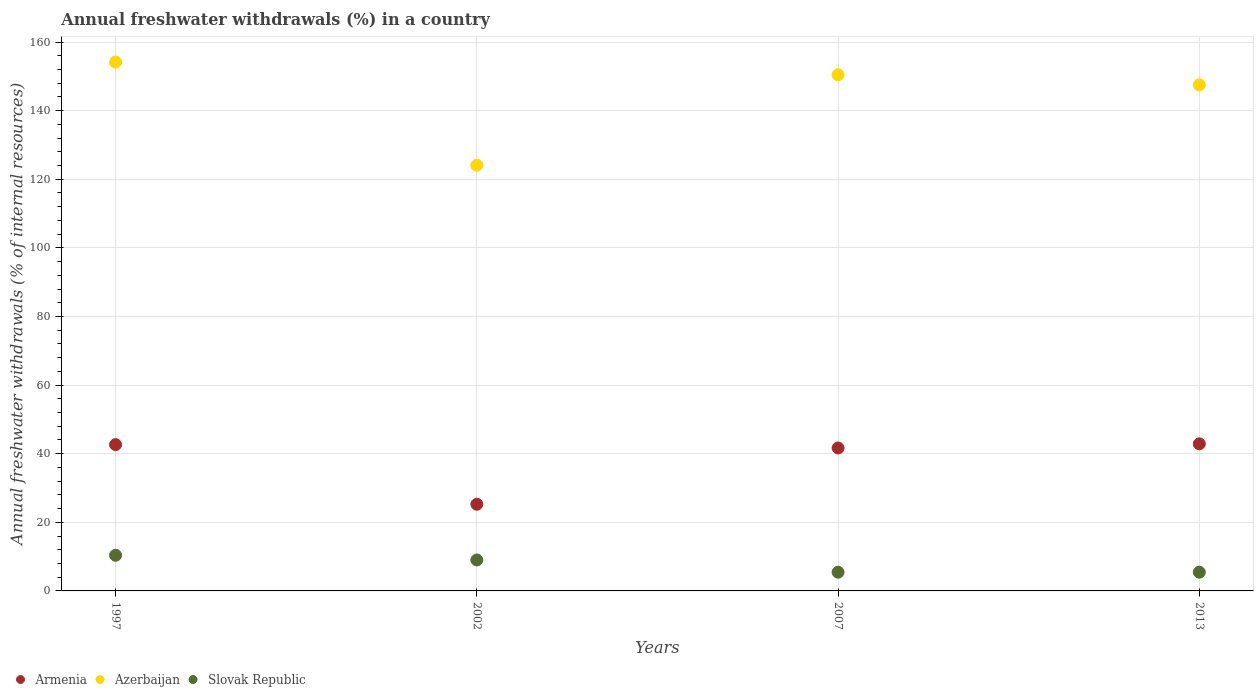How many different coloured dotlines are there?
Your answer should be very brief. 3. Is the number of dotlines equal to the number of legend labels?
Provide a short and direct response. Yes. What is the percentage of annual freshwater withdrawals in Azerbaijan in 2007?
Ensure brevity in your answer.  150.46. Across all years, what is the maximum percentage of annual freshwater withdrawals in Slovak Republic?
Give a very brief answer. 10.4. Across all years, what is the minimum percentage of annual freshwater withdrawals in Armenia?
Offer a terse response. 25.27. In which year was the percentage of annual freshwater withdrawals in Armenia maximum?
Your response must be concise. 2013. In which year was the percentage of annual freshwater withdrawals in Slovak Republic minimum?
Ensure brevity in your answer.  2007. What is the total percentage of annual freshwater withdrawals in Armenia in the graph?
Make the answer very short. 152.46. What is the difference between the percentage of annual freshwater withdrawals in Armenia in 2002 and that in 2007?
Make the answer very short. -16.4. What is the difference between the percentage of annual freshwater withdrawals in Slovak Republic in 2013 and the percentage of annual freshwater withdrawals in Armenia in 2007?
Provide a succinct answer. -36.21. What is the average percentage of annual freshwater withdrawals in Armenia per year?
Offer a very short reply. 38.11. In the year 1997, what is the difference between the percentage of annual freshwater withdrawals in Azerbaijan and percentage of annual freshwater withdrawals in Slovak Republic?
Your answer should be very brief. 143.76. What is the ratio of the percentage of annual freshwater withdrawals in Slovak Republic in 2002 to that in 2013?
Give a very brief answer. 1.65. Is the percentage of annual freshwater withdrawals in Slovak Republic in 2007 less than that in 2013?
Your answer should be compact. No. Is the difference between the percentage of annual freshwater withdrawals in Azerbaijan in 1997 and 2007 greater than the difference between the percentage of annual freshwater withdrawals in Slovak Republic in 1997 and 2007?
Ensure brevity in your answer.  No. What is the difference between the highest and the second highest percentage of annual freshwater withdrawals in Slovak Republic?
Your response must be concise. 1.37. What is the difference between the highest and the lowest percentage of annual freshwater withdrawals in Azerbaijan?
Offer a terse response. 30.07. Does the percentage of annual freshwater withdrawals in Azerbaijan monotonically increase over the years?
Offer a terse response. No. Is the percentage of annual freshwater withdrawals in Slovak Republic strictly greater than the percentage of annual freshwater withdrawals in Azerbaijan over the years?
Your answer should be very brief. No. Is the percentage of annual freshwater withdrawals in Slovak Republic strictly less than the percentage of annual freshwater withdrawals in Armenia over the years?
Your answer should be very brief. Yes. How many years are there in the graph?
Provide a short and direct response. 4. Are the values on the major ticks of Y-axis written in scientific E-notation?
Provide a short and direct response. No. Does the graph contain any zero values?
Your answer should be compact. No. What is the title of the graph?
Your response must be concise. Annual freshwater withdrawals (%) in a country. Does "Vanuatu" appear as one of the legend labels in the graph?
Provide a succinct answer. No. What is the label or title of the Y-axis?
Ensure brevity in your answer.  Annual freshwater withdrawals (% of internal resources). What is the Annual freshwater withdrawals (% of internal resources) of Armenia in 1997?
Provide a succinct answer. 42.64. What is the Annual freshwater withdrawals (% of internal resources) in Azerbaijan in 1997?
Ensure brevity in your answer.  154.16. What is the Annual freshwater withdrawals (% of internal resources) of Slovak Republic in 1997?
Keep it short and to the point. 10.4. What is the Annual freshwater withdrawals (% of internal resources) of Armenia in 2002?
Provide a succinct answer. 25.27. What is the Annual freshwater withdrawals (% of internal resources) in Azerbaijan in 2002?
Keep it short and to the point. 124.09. What is the Annual freshwater withdrawals (% of internal resources) in Slovak Republic in 2002?
Make the answer very short. 9.02. What is the Annual freshwater withdrawals (% of internal resources) in Armenia in 2007?
Offer a terse response. 41.67. What is the Annual freshwater withdrawals (% of internal resources) of Azerbaijan in 2007?
Make the answer very short. 150.46. What is the Annual freshwater withdrawals (% of internal resources) of Slovak Republic in 2007?
Ensure brevity in your answer.  5.46. What is the Annual freshwater withdrawals (% of internal resources) in Armenia in 2013?
Your answer should be very brief. 42.88. What is the Annual freshwater withdrawals (% of internal resources) in Azerbaijan in 2013?
Offer a very short reply. 147.5. What is the Annual freshwater withdrawals (% of internal resources) in Slovak Republic in 2013?
Provide a succinct answer. 5.46. Across all years, what is the maximum Annual freshwater withdrawals (% of internal resources) of Armenia?
Ensure brevity in your answer.  42.88. Across all years, what is the maximum Annual freshwater withdrawals (% of internal resources) in Azerbaijan?
Make the answer very short. 154.16. Across all years, what is the maximum Annual freshwater withdrawals (% of internal resources) in Slovak Republic?
Make the answer very short. 10.4. Across all years, what is the minimum Annual freshwater withdrawals (% of internal resources) of Armenia?
Provide a succinct answer. 25.27. Across all years, what is the minimum Annual freshwater withdrawals (% of internal resources) of Azerbaijan?
Provide a succinct answer. 124.09. Across all years, what is the minimum Annual freshwater withdrawals (% of internal resources) in Slovak Republic?
Give a very brief answer. 5.46. What is the total Annual freshwater withdrawals (% of internal resources) of Armenia in the graph?
Offer a terse response. 152.46. What is the total Annual freshwater withdrawals (% of internal resources) of Azerbaijan in the graph?
Your answer should be very brief. 576.22. What is the total Annual freshwater withdrawals (% of internal resources) of Slovak Republic in the graph?
Your response must be concise. 30.34. What is the difference between the Annual freshwater withdrawals (% of internal resources) of Armenia in 1997 and that in 2002?
Keep it short and to the point. 17.38. What is the difference between the Annual freshwater withdrawals (% of internal resources) of Azerbaijan in 1997 and that in 2002?
Provide a succinct answer. 30.07. What is the difference between the Annual freshwater withdrawals (% of internal resources) in Slovak Republic in 1997 and that in 2002?
Ensure brevity in your answer.  1.37. What is the difference between the Annual freshwater withdrawals (% of internal resources) in Armenia in 1997 and that in 2007?
Make the answer very short. 0.98. What is the difference between the Annual freshwater withdrawals (% of internal resources) of Azerbaijan in 1997 and that in 2007?
Give a very brief answer. 3.7. What is the difference between the Annual freshwater withdrawals (% of internal resources) in Slovak Republic in 1997 and that in 2007?
Provide a succinct answer. 4.94. What is the difference between the Annual freshwater withdrawals (% of internal resources) in Armenia in 1997 and that in 2013?
Provide a short and direct response. -0.23. What is the difference between the Annual freshwater withdrawals (% of internal resources) in Azerbaijan in 1997 and that in 2013?
Your response must be concise. 6.65. What is the difference between the Annual freshwater withdrawals (% of internal resources) of Slovak Republic in 1997 and that in 2013?
Give a very brief answer. 4.94. What is the difference between the Annual freshwater withdrawals (% of internal resources) of Armenia in 2002 and that in 2007?
Provide a succinct answer. -16.4. What is the difference between the Annual freshwater withdrawals (% of internal resources) of Azerbaijan in 2002 and that in 2007?
Provide a short and direct response. -26.37. What is the difference between the Annual freshwater withdrawals (% of internal resources) in Slovak Republic in 2002 and that in 2007?
Make the answer very short. 3.56. What is the difference between the Annual freshwater withdrawals (% of internal resources) of Armenia in 2002 and that in 2013?
Offer a very short reply. -17.61. What is the difference between the Annual freshwater withdrawals (% of internal resources) in Azerbaijan in 2002 and that in 2013?
Offer a terse response. -23.41. What is the difference between the Annual freshwater withdrawals (% of internal resources) in Slovak Republic in 2002 and that in 2013?
Offer a very short reply. 3.56. What is the difference between the Annual freshwater withdrawals (% of internal resources) in Armenia in 2007 and that in 2013?
Ensure brevity in your answer.  -1.21. What is the difference between the Annual freshwater withdrawals (% of internal resources) of Azerbaijan in 2007 and that in 2013?
Your response must be concise. 2.96. What is the difference between the Annual freshwater withdrawals (% of internal resources) of Slovak Republic in 2007 and that in 2013?
Provide a succinct answer. 0. What is the difference between the Annual freshwater withdrawals (% of internal resources) in Armenia in 1997 and the Annual freshwater withdrawals (% of internal resources) in Azerbaijan in 2002?
Keep it short and to the point. -81.45. What is the difference between the Annual freshwater withdrawals (% of internal resources) of Armenia in 1997 and the Annual freshwater withdrawals (% of internal resources) of Slovak Republic in 2002?
Make the answer very short. 33.62. What is the difference between the Annual freshwater withdrawals (% of internal resources) in Azerbaijan in 1997 and the Annual freshwater withdrawals (% of internal resources) in Slovak Republic in 2002?
Your response must be concise. 145.14. What is the difference between the Annual freshwater withdrawals (% of internal resources) of Armenia in 1997 and the Annual freshwater withdrawals (% of internal resources) of Azerbaijan in 2007?
Keep it short and to the point. -107.82. What is the difference between the Annual freshwater withdrawals (% of internal resources) of Armenia in 1997 and the Annual freshwater withdrawals (% of internal resources) of Slovak Republic in 2007?
Provide a succinct answer. 37.18. What is the difference between the Annual freshwater withdrawals (% of internal resources) of Azerbaijan in 1997 and the Annual freshwater withdrawals (% of internal resources) of Slovak Republic in 2007?
Give a very brief answer. 148.7. What is the difference between the Annual freshwater withdrawals (% of internal resources) in Armenia in 1997 and the Annual freshwater withdrawals (% of internal resources) in Azerbaijan in 2013?
Provide a short and direct response. -104.86. What is the difference between the Annual freshwater withdrawals (% of internal resources) of Armenia in 1997 and the Annual freshwater withdrawals (% of internal resources) of Slovak Republic in 2013?
Your answer should be compact. 37.18. What is the difference between the Annual freshwater withdrawals (% of internal resources) in Azerbaijan in 1997 and the Annual freshwater withdrawals (% of internal resources) in Slovak Republic in 2013?
Offer a very short reply. 148.7. What is the difference between the Annual freshwater withdrawals (% of internal resources) of Armenia in 2002 and the Annual freshwater withdrawals (% of internal resources) of Azerbaijan in 2007?
Your response must be concise. -125.2. What is the difference between the Annual freshwater withdrawals (% of internal resources) of Armenia in 2002 and the Annual freshwater withdrawals (% of internal resources) of Slovak Republic in 2007?
Ensure brevity in your answer.  19.81. What is the difference between the Annual freshwater withdrawals (% of internal resources) in Azerbaijan in 2002 and the Annual freshwater withdrawals (% of internal resources) in Slovak Republic in 2007?
Your answer should be compact. 118.63. What is the difference between the Annual freshwater withdrawals (% of internal resources) of Armenia in 2002 and the Annual freshwater withdrawals (% of internal resources) of Azerbaijan in 2013?
Give a very brief answer. -122.24. What is the difference between the Annual freshwater withdrawals (% of internal resources) of Armenia in 2002 and the Annual freshwater withdrawals (% of internal resources) of Slovak Republic in 2013?
Your response must be concise. 19.81. What is the difference between the Annual freshwater withdrawals (% of internal resources) in Azerbaijan in 2002 and the Annual freshwater withdrawals (% of internal resources) in Slovak Republic in 2013?
Your response must be concise. 118.63. What is the difference between the Annual freshwater withdrawals (% of internal resources) of Armenia in 2007 and the Annual freshwater withdrawals (% of internal resources) of Azerbaijan in 2013?
Ensure brevity in your answer.  -105.84. What is the difference between the Annual freshwater withdrawals (% of internal resources) in Armenia in 2007 and the Annual freshwater withdrawals (% of internal resources) in Slovak Republic in 2013?
Your response must be concise. 36.21. What is the difference between the Annual freshwater withdrawals (% of internal resources) of Azerbaijan in 2007 and the Annual freshwater withdrawals (% of internal resources) of Slovak Republic in 2013?
Your answer should be compact. 145. What is the average Annual freshwater withdrawals (% of internal resources) in Armenia per year?
Ensure brevity in your answer.  38.11. What is the average Annual freshwater withdrawals (% of internal resources) of Azerbaijan per year?
Give a very brief answer. 144.05. What is the average Annual freshwater withdrawals (% of internal resources) in Slovak Republic per year?
Keep it short and to the point. 7.59. In the year 1997, what is the difference between the Annual freshwater withdrawals (% of internal resources) of Armenia and Annual freshwater withdrawals (% of internal resources) of Azerbaijan?
Make the answer very short. -111.51. In the year 1997, what is the difference between the Annual freshwater withdrawals (% of internal resources) of Armenia and Annual freshwater withdrawals (% of internal resources) of Slovak Republic?
Make the answer very short. 32.25. In the year 1997, what is the difference between the Annual freshwater withdrawals (% of internal resources) in Azerbaijan and Annual freshwater withdrawals (% of internal resources) in Slovak Republic?
Keep it short and to the point. 143.76. In the year 2002, what is the difference between the Annual freshwater withdrawals (% of internal resources) in Armenia and Annual freshwater withdrawals (% of internal resources) in Azerbaijan?
Ensure brevity in your answer.  -98.83. In the year 2002, what is the difference between the Annual freshwater withdrawals (% of internal resources) in Armenia and Annual freshwater withdrawals (% of internal resources) in Slovak Republic?
Keep it short and to the point. 16.24. In the year 2002, what is the difference between the Annual freshwater withdrawals (% of internal resources) of Azerbaijan and Annual freshwater withdrawals (% of internal resources) of Slovak Republic?
Make the answer very short. 115.07. In the year 2007, what is the difference between the Annual freshwater withdrawals (% of internal resources) of Armenia and Annual freshwater withdrawals (% of internal resources) of Azerbaijan?
Your response must be concise. -108.79. In the year 2007, what is the difference between the Annual freshwater withdrawals (% of internal resources) in Armenia and Annual freshwater withdrawals (% of internal resources) in Slovak Republic?
Offer a very short reply. 36.21. In the year 2007, what is the difference between the Annual freshwater withdrawals (% of internal resources) of Azerbaijan and Annual freshwater withdrawals (% of internal resources) of Slovak Republic?
Ensure brevity in your answer.  145. In the year 2013, what is the difference between the Annual freshwater withdrawals (% of internal resources) of Armenia and Annual freshwater withdrawals (% of internal resources) of Azerbaijan?
Keep it short and to the point. -104.63. In the year 2013, what is the difference between the Annual freshwater withdrawals (% of internal resources) of Armenia and Annual freshwater withdrawals (% of internal resources) of Slovak Republic?
Make the answer very short. 37.42. In the year 2013, what is the difference between the Annual freshwater withdrawals (% of internal resources) of Azerbaijan and Annual freshwater withdrawals (% of internal resources) of Slovak Republic?
Ensure brevity in your answer.  142.04. What is the ratio of the Annual freshwater withdrawals (% of internal resources) of Armenia in 1997 to that in 2002?
Offer a terse response. 1.69. What is the ratio of the Annual freshwater withdrawals (% of internal resources) in Azerbaijan in 1997 to that in 2002?
Give a very brief answer. 1.24. What is the ratio of the Annual freshwater withdrawals (% of internal resources) of Slovak Republic in 1997 to that in 2002?
Your answer should be very brief. 1.15. What is the ratio of the Annual freshwater withdrawals (% of internal resources) of Armenia in 1997 to that in 2007?
Provide a short and direct response. 1.02. What is the ratio of the Annual freshwater withdrawals (% of internal resources) of Azerbaijan in 1997 to that in 2007?
Provide a succinct answer. 1.02. What is the ratio of the Annual freshwater withdrawals (% of internal resources) in Slovak Republic in 1997 to that in 2007?
Provide a short and direct response. 1.9. What is the ratio of the Annual freshwater withdrawals (% of internal resources) of Azerbaijan in 1997 to that in 2013?
Offer a terse response. 1.05. What is the ratio of the Annual freshwater withdrawals (% of internal resources) of Slovak Republic in 1997 to that in 2013?
Provide a succinct answer. 1.9. What is the ratio of the Annual freshwater withdrawals (% of internal resources) of Armenia in 2002 to that in 2007?
Offer a terse response. 0.61. What is the ratio of the Annual freshwater withdrawals (% of internal resources) of Azerbaijan in 2002 to that in 2007?
Your answer should be very brief. 0.82. What is the ratio of the Annual freshwater withdrawals (% of internal resources) of Slovak Republic in 2002 to that in 2007?
Provide a short and direct response. 1.65. What is the ratio of the Annual freshwater withdrawals (% of internal resources) of Armenia in 2002 to that in 2013?
Ensure brevity in your answer.  0.59. What is the ratio of the Annual freshwater withdrawals (% of internal resources) of Azerbaijan in 2002 to that in 2013?
Give a very brief answer. 0.84. What is the ratio of the Annual freshwater withdrawals (% of internal resources) in Slovak Republic in 2002 to that in 2013?
Your answer should be compact. 1.65. What is the ratio of the Annual freshwater withdrawals (% of internal resources) of Armenia in 2007 to that in 2013?
Give a very brief answer. 0.97. What is the ratio of the Annual freshwater withdrawals (% of internal resources) in Azerbaijan in 2007 to that in 2013?
Your answer should be very brief. 1.02. What is the ratio of the Annual freshwater withdrawals (% of internal resources) in Slovak Republic in 2007 to that in 2013?
Give a very brief answer. 1. What is the difference between the highest and the second highest Annual freshwater withdrawals (% of internal resources) in Armenia?
Make the answer very short. 0.23. What is the difference between the highest and the second highest Annual freshwater withdrawals (% of internal resources) of Azerbaijan?
Offer a very short reply. 3.7. What is the difference between the highest and the second highest Annual freshwater withdrawals (% of internal resources) in Slovak Republic?
Your answer should be very brief. 1.37. What is the difference between the highest and the lowest Annual freshwater withdrawals (% of internal resources) of Armenia?
Make the answer very short. 17.61. What is the difference between the highest and the lowest Annual freshwater withdrawals (% of internal resources) of Azerbaijan?
Your answer should be compact. 30.07. What is the difference between the highest and the lowest Annual freshwater withdrawals (% of internal resources) in Slovak Republic?
Give a very brief answer. 4.94. 